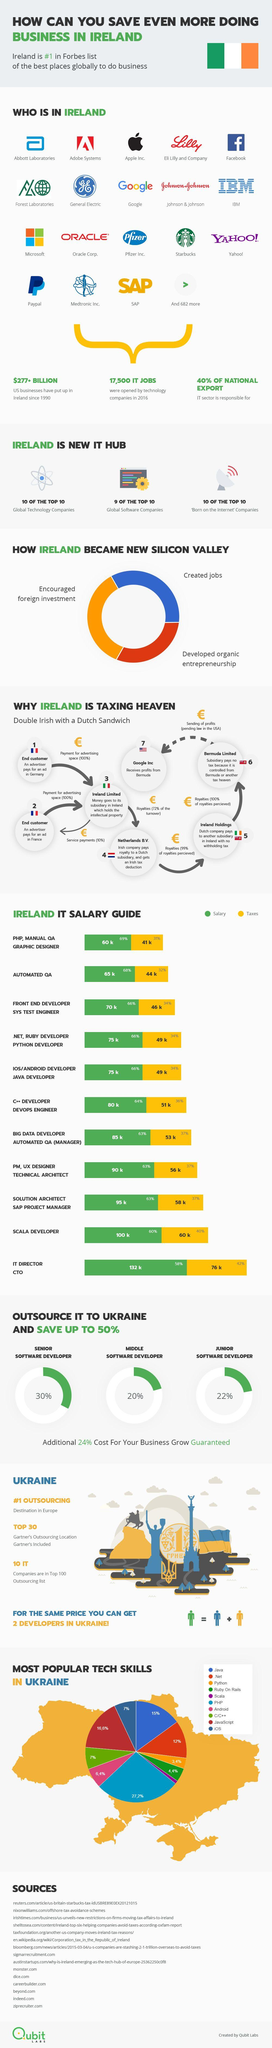List a handful of essential elements in this visual. The IT director/CTO in Ireland is subject to a tax of approximately 76,000 on their salary. The tax imposed on the salary of a Scala developer in Ireland is approximately 60,000 euros. In Ireland, only 40% of the national export is from the IT sector. The amount of money invested by US businesses in Ireland since 1990 is over $277 BILLION. In Ukraine, Scala is the least popular tech skill. 